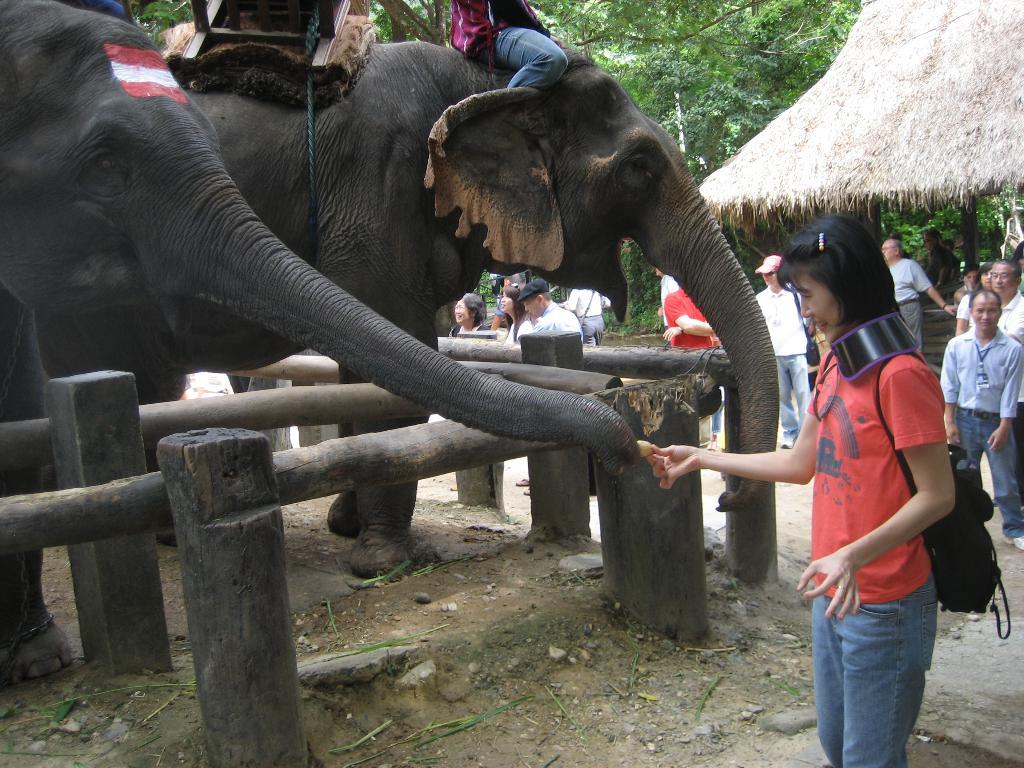What are the persons doing in the image? The persons are sitting on elephants in the image. Are there any persons not on elephants in the image? Yes, some persons are standing on the ground in the image. What can be seen in the background of the image? There are trees and huts in the background of the image. What type of plantation can be seen in the image? There is no plantation present in the image; it features persons sitting on elephants and standing on the ground, with trees and huts in the background. How many pizzas are being served to the persons in the image? There are no pizzas present in the image. 